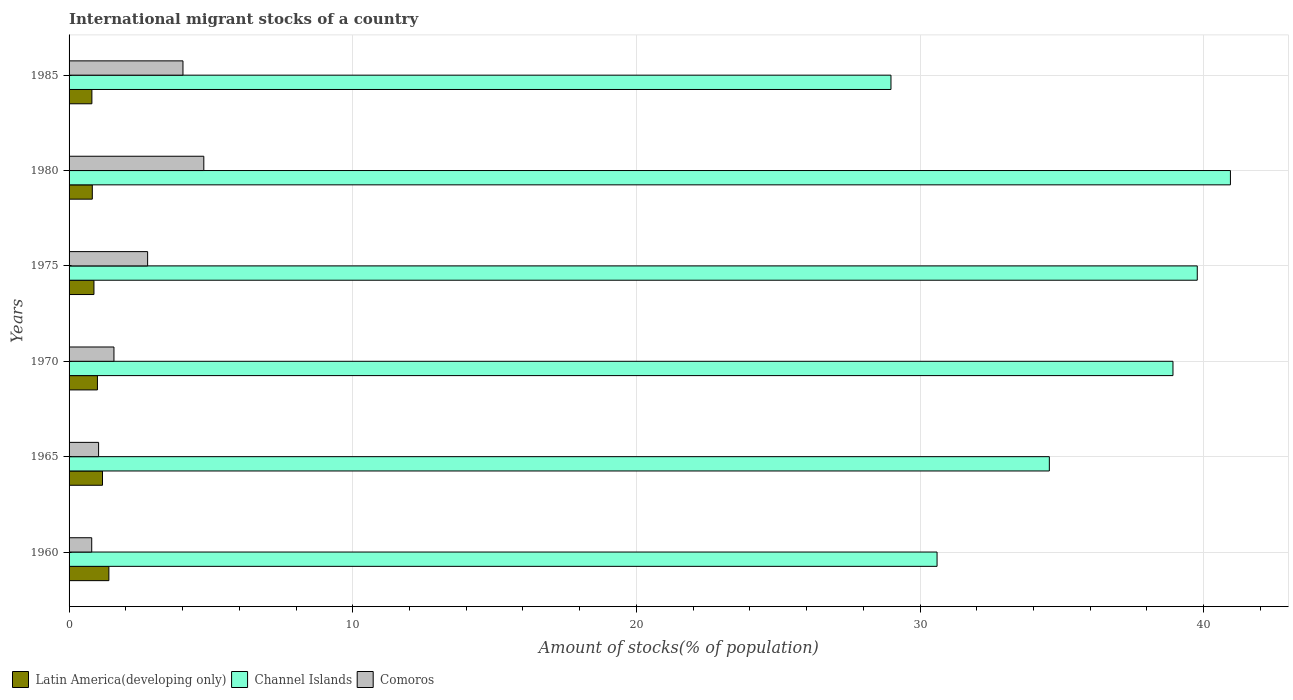How many different coloured bars are there?
Make the answer very short. 3. Are the number of bars on each tick of the Y-axis equal?
Your response must be concise. Yes. How many bars are there on the 4th tick from the top?
Your answer should be compact. 3. How many bars are there on the 6th tick from the bottom?
Offer a very short reply. 3. What is the label of the 5th group of bars from the top?
Keep it short and to the point. 1965. What is the amount of stocks in in Latin America(developing only) in 1985?
Provide a succinct answer. 0.8. Across all years, what is the maximum amount of stocks in in Channel Islands?
Offer a very short reply. 40.94. Across all years, what is the minimum amount of stocks in in Channel Islands?
Give a very brief answer. 28.98. In which year was the amount of stocks in in Latin America(developing only) maximum?
Provide a succinct answer. 1960. In which year was the amount of stocks in in Latin America(developing only) minimum?
Offer a very short reply. 1985. What is the total amount of stocks in in Channel Islands in the graph?
Ensure brevity in your answer.  213.76. What is the difference between the amount of stocks in in Channel Islands in 1970 and that in 1975?
Make the answer very short. -0.86. What is the difference between the amount of stocks in in Channel Islands in 1985 and the amount of stocks in in Comoros in 1975?
Your response must be concise. 26.21. What is the average amount of stocks in in Latin America(developing only) per year?
Provide a succinct answer. 1.01. In the year 1985, what is the difference between the amount of stocks in in Channel Islands and amount of stocks in in Latin America(developing only)?
Your response must be concise. 28.17. In how many years, is the amount of stocks in in Latin America(developing only) greater than 24 %?
Keep it short and to the point. 0. What is the ratio of the amount of stocks in in Latin America(developing only) in 1960 to that in 1985?
Your answer should be compact. 1.74. Is the amount of stocks in in Comoros in 1960 less than that in 1985?
Your response must be concise. Yes. What is the difference between the highest and the second highest amount of stocks in in Latin America(developing only)?
Make the answer very short. 0.22. What is the difference between the highest and the lowest amount of stocks in in Channel Islands?
Your answer should be very brief. 11.97. In how many years, is the amount of stocks in in Comoros greater than the average amount of stocks in in Comoros taken over all years?
Offer a very short reply. 3. Is the sum of the amount of stocks in in Comoros in 1960 and 1980 greater than the maximum amount of stocks in in Latin America(developing only) across all years?
Your response must be concise. Yes. What does the 2nd bar from the top in 1965 represents?
Your response must be concise. Channel Islands. What does the 3rd bar from the bottom in 1970 represents?
Make the answer very short. Comoros. What is the difference between two consecutive major ticks on the X-axis?
Your answer should be compact. 10. Where does the legend appear in the graph?
Provide a short and direct response. Bottom left. How many legend labels are there?
Provide a short and direct response. 3. What is the title of the graph?
Offer a very short reply. International migrant stocks of a country. Does "Andorra" appear as one of the legend labels in the graph?
Offer a very short reply. No. What is the label or title of the X-axis?
Provide a short and direct response. Amount of stocks(% of population). What is the label or title of the Y-axis?
Your answer should be compact. Years. What is the Amount of stocks(% of population) in Latin America(developing only) in 1960?
Offer a terse response. 1.4. What is the Amount of stocks(% of population) in Channel Islands in 1960?
Ensure brevity in your answer.  30.6. What is the Amount of stocks(% of population) in Comoros in 1960?
Offer a very short reply. 0.8. What is the Amount of stocks(% of population) of Latin America(developing only) in 1965?
Provide a short and direct response. 1.18. What is the Amount of stocks(% of population) of Channel Islands in 1965?
Make the answer very short. 34.56. What is the Amount of stocks(% of population) of Comoros in 1965?
Your response must be concise. 1.04. What is the Amount of stocks(% of population) in Latin America(developing only) in 1970?
Offer a very short reply. 1. What is the Amount of stocks(% of population) in Channel Islands in 1970?
Offer a very short reply. 38.92. What is the Amount of stocks(% of population) of Comoros in 1970?
Offer a very short reply. 1.58. What is the Amount of stocks(% of population) of Latin America(developing only) in 1975?
Provide a succinct answer. 0.88. What is the Amount of stocks(% of population) of Channel Islands in 1975?
Ensure brevity in your answer.  39.77. What is the Amount of stocks(% of population) of Comoros in 1975?
Ensure brevity in your answer.  2.77. What is the Amount of stocks(% of population) of Latin America(developing only) in 1980?
Your response must be concise. 0.82. What is the Amount of stocks(% of population) of Channel Islands in 1980?
Make the answer very short. 40.94. What is the Amount of stocks(% of population) in Comoros in 1980?
Your answer should be very brief. 4.75. What is the Amount of stocks(% of population) of Latin America(developing only) in 1985?
Provide a short and direct response. 0.8. What is the Amount of stocks(% of population) in Channel Islands in 1985?
Your response must be concise. 28.98. What is the Amount of stocks(% of population) in Comoros in 1985?
Your answer should be compact. 4.02. Across all years, what is the maximum Amount of stocks(% of population) in Latin America(developing only)?
Keep it short and to the point. 1.4. Across all years, what is the maximum Amount of stocks(% of population) in Channel Islands?
Provide a short and direct response. 40.94. Across all years, what is the maximum Amount of stocks(% of population) of Comoros?
Offer a terse response. 4.75. Across all years, what is the minimum Amount of stocks(% of population) in Latin America(developing only)?
Your answer should be compact. 0.8. Across all years, what is the minimum Amount of stocks(% of population) in Channel Islands?
Your answer should be compact. 28.98. Across all years, what is the minimum Amount of stocks(% of population) of Comoros?
Provide a short and direct response. 0.8. What is the total Amount of stocks(% of population) in Latin America(developing only) in the graph?
Keep it short and to the point. 6.08. What is the total Amount of stocks(% of population) of Channel Islands in the graph?
Offer a very short reply. 213.76. What is the total Amount of stocks(% of population) of Comoros in the graph?
Ensure brevity in your answer.  14.96. What is the difference between the Amount of stocks(% of population) in Latin America(developing only) in 1960 and that in 1965?
Give a very brief answer. 0.22. What is the difference between the Amount of stocks(% of population) of Channel Islands in 1960 and that in 1965?
Give a very brief answer. -3.96. What is the difference between the Amount of stocks(% of population) in Comoros in 1960 and that in 1965?
Provide a succinct answer. -0.24. What is the difference between the Amount of stocks(% of population) in Latin America(developing only) in 1960 and that in 1970?
Your response must be concise. 0.4. What is the difference between the Amount of stocks(% of population) of Channel Islands in 1960 and that in 1970?
Offer a terse response. -8.32. What is the difference between the Amount of stocks(% of population) in Comoros in 1960 and that in 1970?
Your answer should be very brief. -0.78. What is the difference between the Amount of stocks(% of population) in Latin America(developing only) in 1960 and that in 1975?
Provide a succinct answer. 0.53. What is the difference between the Amount of stocks(% of population) in Channel Islands in 1960 and that in 1975?
Make the answer very short. -9.17. What is the difference between the Amount of stocks(% of population) in Comoros in 1960 and that in 1975?
Ensure brevity in your answer.  -1.97. What is the difference between the Amount of stocks(% of population) in Latin America(developing only) in 1960 and that in 1980?
Your response must be concise. 0.58. What is the difference between the Amount of stocks(% of population) in Channel Islands in 1960 and that in 1980?
Make the answer very short. -10.34. What is the difference between the Amount of stocks(% of population) of Comoros in 1960 and that in 1980?
Give a very brief answer. -3.95. What is the difference between the Amount of stocks(% of population) in Latin America(developing only) in 1960 and that in 1985?
Your answer should be very brief. 0.6. What is the difference between the Amount of stocks(% of population) in Channel Islands in 1960 and that in 1985?
Your answer should be very brief. 1.62. What is the difference between the Amount of stocks(% of population) in Comoros in 1960 and that in 1985?
Your answer should be compact. -3.22. What is the difference between the Amount of stocks(% of population) of Latin America(developing only) in 1965 and that in 1970?
Ensure brevity in your answer.  0.18. What is the difference between the Amount of stocks(% of population) in Channel Islands in 1965 and that in 1970?
Give a very brief answer. -4.36. What is the difference between the Amount of stocks(% of population) of Comoros in 1965 and that in 1970?
Make the answer very short. -0.54. What is the difference between the Amount of stocks(% of population) in Latin America(developing only) in 1965 and that in 1975?
Ensure brevity in your answer.  0.3. What is the difference between the Amount of stocks(% of population) of Channel Islands in 1965 and that in 1975?
Your response must be concise. -5.22. What is the difference between the Amount of stocks(% of population) in Comoros in 1965 and that in 1975?
Your answer should be very brief. -1.73. What is the difference between the Amount of stocks(% of population) in Latin America(developing only) in 1965 and that in 1980?
Your response must be concise. 0.36. What is the difference between the Amount of stocks(% of population) of Channel Islands in 1965 and that in 1980?
Keep it short and to the point. -6.38. What is the difference between the Amount of stocks(% of population) in Comoros in 1965 and that in 1980?
Your response must be concise. -3.71. What is the difference between the Amount of stocks(% of population) of Latin America(developing only) in 1965 and that in 1985?
Provide a short and direct response. 0.37. What is the difference between the Amount of stocks(% of population) in Channel Islands in 1965 and that in 1985?
Your response must be concise. 5.58. What is the difference between the Amount of stocks(% of population) in Comoros in 1965 and that in 1985?
Ensure brevity in your answer.  -2.97. What is the difference between the Amount of stocks(% of population) in Latin America(developing only) in 1970 and that in 1975?
Ensure brevity in your answer.  0.12. What is the difference between the Amount of stocks(% of population) of Channel Islands in 1970 and that in 1975?
Provide a succinct answer. -0.86. What is the difference between the Amount of stocks(% of population) in Comoros in 1970 and that in 1975?
Make the answer very short. -1.19. What is the difference between the Amount of stocks(% of population) in Latin America(developing only) in 1970 and that in 1980?
Make the answer very short. 0.18. What is the difference between the Amount of stocks(% of population) in Channel Islands in 1970 and that in 1980?
Ensure brevity in your answer.  -2.03. What is the difference between the Amount of stocks(% of population) of Comoros in 1970 and that in 1980?
Your answer should be compact. -3.17. What is the difference between the Amount of stocks(% of population) in Latin America(developing only) in 1970 and that in 1985?
Give a very brief answer. 0.2. What is the difference between the Amount of stocks(% of population) of Channel Islands in 1970 and that in 1985?
Make the answer very short. 9.94. What is the difference between the Amount of stocks(% of population) of Comoros in 1970 and that in 1985?
Ensure brevity in your answer.  -2.43. What is the difference between the Amount of stocks(% of population) in Latin America(developing only) in 1975 and that in 1980?
Make the answer very short. 0.06. What is the difference between the Amount of stocks(% of population) in Channel Islands in 1975 and that in 1980?
Your response must be concise. -1.17. What is the difference between the Amount of stocks(% of population) in Comoros in 1975 and that in 1980?
Provide a succinct answer. -1.98. What is the difference between the Amount of stocks(% of population) of Latin America(developing only) in 1975 and that in 1985?
Offer a very short reply. 0.07. What is the difference between the Amount of stocks(% of population) in Channel Islands in 1975 and that in 1985?
Keep it short and to the point. 10.8. What is the difference between the Amount of stocks(% of population) in Comoros in 1975 and that in 1985?
Offer a very short reply. -1.25. What is the difference between the Amount of stocks(% of population) in Latin America(developing only) in 1980 and that in 1985?
Give a very brief answer. 0.02. What is the difference between the Amount of stocks(% of population) of Channel Islands in 1980 and that in 1985?
Keep it short and to the point. 11.97. What is the difference between the Amount of stocks(% of population) in Comoros in 1980 and that in 1985?
Offer a very short reply. 0.73. What is the difference between the Amount of stocks(% of population) of Latin America(developing only) in 1960 and the Amount of stocks(% of population) of Channel Islands in 1965?
Keep it short and to the point. -33.15. What is the difference between the Amount of stocks(% of population) in Latin America(developing only) in 1960 and the Amount of stocks(% of population) in Comoros in 1965?
Provide a succinct answer. 0.36. What is the difference between the Amount of stocks(% of population) in Channel Islands in 1960 and the Amount of stocks(% of population) in Comoros in 1965?
Your response must be concise. 29.56. What is the difference between the Amount of stocks(% of population) in Latin America(developing only) in 1960 and the Amount of stocks(% of population) in Channel Islands in 1970?
Offer a terse response. -37.51. What is the difference between the Amount of stocks(% of population) in Latin America(developing only) in 1960 and the Amount of stocks(% of population) in Comoros in 1970?
Offer a terse response. -0.18. What is the difference between the Amount of stocks(% of population) in Channel Islands in 1960 and the Amount of stocks(% of population) in Comoros in 1970?
Your response must be concise. 29.02. What is the difference between the Amount of stocks(% of population) in Latin America(developing only) in 1960 and the Amount of stocks(% of population) in Channel Islands in 1975?
Provide a short and direct response. -38.37. What is the difference between the Amount of stocks(% of population) of Latin America(developing only) in 1960 and the Amount of stocks(% of population) of Comoros in 1975?
Give a very brief answer. -1.37. What is the difference between the Amount of stocks(% of population) of Channel Islands in 1960 and the Amount of stocks(% of population) of Comoros in 1975?
Provide a short and direct response. 27.83. What is the difference between the Amount of stocks(% of population) in Latin America(developing only) in 1960 and the Amount of stocks(% of population) in Channel Islands in 1980?
Your answer should be very brief. -39.54. What is the difference between the Amount of stocks(% of population) of Latin America(developing only) in 1960 and the Amount of stocks(% of population) of Comoros in 1980?
Keep it short and to the point. -3.35. What is the difference between the Amount of stocks(% of population) in Channel Islands in 1960 and the Amount of stocks(% of population) in Comoros in 1980?
Offer a very short reply. 25.85. What is the difference between the Amount of stocks(% of population) of Latin America(developing only) in 1960 and the Amount of stocks(% of population) of Channel Islands in 1985?
Your response must be concise. -27.57. What is the difference between the Amount of stocks(% of population) in Latin America(developing only) in 1960 and the Amount of stocks(% of population) in Comoros in 1985?
Keep it short and to the point. -2.61. What is the difference between the Amount of stocks(% of population) of Channel Islands in 1960 and the Amount of stocks(% of population) of Comoros in 1985?
Offer a terse response. 26.58. What is the difference between the Amount of stocks(% of population) in Latin America(developing only) in 1965 and the Amount of stocks(% of population) in Channel Islands in 1970?
Your response must be concise. -37.74. What is the difference between the Amount of stocks(% of population) in Latin America(developing only) in 1965 and the Amount of stocks(% of population) in Comoros in 1970?
Provide a succinct answer. -0.4. What is the difference between the Amount of stocks(% of population) of Channel Islands in 1965 and the Amount of stocks(% of population) of Comoros in 1970?
Ensure brevity in your answer.  32.98. What is the difference between the Amount of stocks(% of population) in Latin America(developing only) in 1965 and the Amount of stocks(% of population) in Channel Islands in 1975?
Give a very brief answer. -38.59. What is the difference between the Amount of stocks(% of population) in Latin America(developing only) in 1965 and the Amount of stocks(% of population) in Comoros in 1975?
Ensure brevity in your answer.  -1.59. What is the difference between the Amount of stocks(% of population) of Channel Islands in 1965 and the Amount of stocks(% of population) of Comoros in 1975?
Offer a terse response. 31.79. What is the difference between the Amount of stocks(% of population) in Latin America(developing only) in 1965 and the Amount of stocks(% of population) in Channel Islands in 1980?
Offer a very short reply. -39.76. What is the difference between the Amount of stocks(% of population) in Latin America(developing only) in 1965 and the Amount of stocks(% of population) in Comoros in 1980?
Your answer should be compact. -3.57. What is the difference between the Amount of stocks(% of population) in Channel Islands in 1965 and the Amount of stocks(% of population) in Comoros in 1980?
Ensure brevity in your answer.  29.81. What is the difference between the Amount of stocks(% of population) in Latin America(developing only) in 1965 and the Amount of stocks(% of population) in Channel Islands in 1985?
Provide a short and direct response. -27.8. What is the difference between the Amount of stocks(% of population) in Latin America(developing only) in 1965 and the Amount of stocks(% of population) in Comoros in 1985?
Provide a succinct answer. -2.84. What is the difference between the Amount of stocks(% of population) of Channel Islands in 1965 and the Amount of stocks(% of population) of Comoros in 1985?
Give a very brief answer. 30.54. What is the difference between the Amount of stocks(% of population) of Latin America(developing only) in 1970 and the Amount of stocks(% of population) of Channel Islands in 1975?
Ensure brevity in your answer.  -38.77. What is the difference between the Amount of stocks(% of population) in Latin America(developing only) in 1970 and the Amount of stocks(% of population) in Comoros in 1975?
Your answer should be very brief. -1.77. What is the difference between the Amount of stocks(% of population) of Channel Islands in 1970 and the Amount of stocks(% of population) of Comoros in 1975?
Provide a short and direct response. 36.15. What is the difference between the Amount of stocks(% of population) in Latin America(developing only) in 1970 and the Amount of stocks(% of population) in Channel Islands in 1980?
Your response must be concise. -39.94. What is the difference between the Amount of stocks(% of population) of Latin America(developing only) in 1970 and the Amount of stocks(% of population) of Comoros in 1980?
Your answer should be compact. -3.75. What is the difference between the Amount of stocks(% of population) in Channel Islands in 1970 and the Amount of stocks(% of population) in Comoros in 1980?
Give a very brief answer. 34.17. What is the difference between the Amount of stocks(% of population) of Latin America(developing only) in 1970 and the Amount of stocks(% of population) of Channel Islands in 1985?
Give a very brief answer. -27.98. What is the difference between the Amount of stocks(% of population) of Latin America(developing only) in 1970 and the Amount of stocks(% of population) of Comoros in 1985?
Provide a succinct answer. -3.02. What is the difference between the Amount of stocks(% of population) in Channel Islands in 1970 and the Amount of stocks(% of population) in Comoros in 1985?
Your answer should be compact. 34.9. What is the difference between the Amount of stocks(% of population) of Latin America(developing only) in 1975 and the Amount of stocks(% of population) of Channel Islands in 1980?
Your response must be concise. -40.06. What is the difference between the Amount of stocks(% of population) of Latin America(developing only) in 1975 and the Amount of stocks(% of population) of Comoros in 1980?
Your answer should be very brief. -3.87. What is the difference between the Amount of stocks(% of population) of Channel Islands in 1975 and the Amount of stocks(% of population) of Comoros in 1980?
Your answer should be very brief. 35.02. What is the difference between the Amount of stocks(% of population) of Latin America(developing only) in 1975 and the Amount of stocks(% of population) of Channel Islands in 1985?
Your answer should be very brief. -28.1. What is the difference between the Amount of stocks(% of population) of Latin America(developing only) in 1975 and the Amount of stocks(% of population) of Comoros in 1985?
Your answer should be very brief. -3.14. What is the difference between the Amount of stocks(% of population) in Channel Islands in 1975 and the Amount of stocks(% of population) in Comoros in 1985?
Provide a short and direct response. 35.76. What is the difference between the Amount of stocks(% of population) in Latin America(developing only) in 1980 and the Amount of stocks(% of population) in Channel Islands in 1985?
Offer a very short reply. -28.16. What is the difference between the Amount of stocks(% of population) in Latin America(developing only) in 1980 and the Amount of stocks(% of population) in Comoros in 1985?
Your answer should be very brief. -3.2. What is the difference between the Amount of stocks(% of population) in Channel Islands in 1980 and the Amount of stocks(% of population) in Comoros in 1985?
Give a very brief answer. 36.93. What is the average Amount of stocks(% of population) in Latin America(developing only) per year?
Give a very brief answer. 1.01. What is the average Amount of stocks(% of population) of Channel Islands per year?
Your answer should be very brief. 35.63. What is the average Amount of stocks(% of population) in Comoros per year?
Your response must be concise. 2.49. In the year 1960, what is the difference between the Amount of stocks(% of population) of Latin America(developing only) and Amount of stocks(% of population) of Channel Islands?
Make the answer very short. -29.2. In the year 1960, what is the difference between the Amount of stocks(% of population) of Latin America(developing only) and Amount of stocks(% of population) of Comoros?
Make the answer very short. 0.6. In the year 1960, what is the difference between the Amount of stocks(% of population) in Channel Islands and Amount of stocks(% of population) in Comoros?
Give a very brief answer. 29.8. In the year 1965, what is the difference between the Amount of stocks(% of population) in Latin America(developing only) and Amount of stocks(% of population) in Channel Islands?
Offer a terse response. -33.38. In the year 1965, what is the difference between the Amount of stocks(% of population) in Latin America(developing only) and Amount of stocks(% of population) in Comoros?
Your answer should be compact. 0.14. In the year 1965, what is the difference between the Amount of stocks(% of population) in Channel Islands and Amount of stocks(% of population) in Comoros?
Provide a succinct answer. 33.52. In the year 1970, what is the difference between the Amount of stocks(% of population) of Latin America(developing only) and Amount of stocks(% of population) of Channel Islands?
Keep it short and to the point. -37.92. In the year 1970, what is the difference between the Amount of stocks(% of population) of Latin America(developing only) and Amount of stocks(% of population) of Comoros?
Offer a very short reply. -0.58. In the year 1970, what is the difference between the Amount of stocks(% of population) in Channel Islands and Amount of stocks(% of population) in Comoros?
Offer a very short reply. 37.33. In the year 1975, what is the difference between the Amount of stocks(% of population) in Latin America(developing only) and Amount of stocks(% of population) in Channel Islands?
Make the answer very short. -38.9. In the year 1975, what is the difference between the Amount of stocks(% of population) in Latin America(developing only) and Amount of stocks(% of population) in Comoros?
Offer a terse response. -1.89. In the year 1975, what is the difference between the Amount of stocks(% of population) in Channel Islands and Amount of stocks(% of population) in Comoros?
Provide a succinct answer. 37. In the year 1980, what is the difference between the Amount of stocks(% of population) in Latin America(developing only) and Amount of stocks(% of population) in Channel Islands?
Make the answer very short. -40.12. In the year 1980, what is the difference between the Amount of stocks(% of population) in Latin America(developing only) and Amount of stocks(% of population) in Comoros?
Provide a short and direct response. -3.93. In the year 1980, what is the difference between the Amount of stocks(% of population) of Channel Islands and Amount of stocks(% of population) of Comoros?
Provide a succinct answer. 36.19. In the year 1985, what is the difference between the Amount of stocks(% of population) of Latin America(developing only) and Amount of stocks(% of population) of Channel Islands?
Ensure brevity in your answer.  -28.17. In the year 1985, what is the difference between the Amount of stocks(% of population) of Latin America(developing only) and Amount of stocks(% of population) of Comoros?
Ensure brevity in your answer.  -3.21. In the year 1985, what is the difference between the Amount of stocks(% of population) of Channel Islands and Amount of stocks(% of population) of Comoros?
Provide a short and direct response. 24.96. What is the ratio of the Amount of stocks(% of population) of Latin America(developing only) in 1960 to that in 1965?
Offer a terse response. 1.19. What is the ratio of the Amount of stocks(% of population) of Channel Islands in 1960 to that in 1965?
Ensure brevity in your answer.  0.89. What is the ratio of the Amount of stocks(% of population) in Comoros in 1960 to that in 1965?
Your answer should be very brief. 0.77. What is the ratio of the Amount of stocks(% of population) in Latin America(developing only) in 1960 to that in 1970?
Offer a very short reply. 1.4. What is the ratio of the Amount of stocks(% of population) in Channel Islands in 1960 to that in 1970?
Give a very brief answer. 0.79. What is the ratio of the Amount of stocks(% of population) in Comoros in 1960 to that in 1970?
Offer a very short reply. 0.5. What is the ratio of the Amount of stocks(% of population) of Latin America(developing only) in 1960 to that in 1975?
Give a very brief answer. 1.6. What is the ratio of the Amount of stocks(% of population) of Channel Islands in 1960 to that in 1975?
Offer a terse response. 0.77. What is the ratio of the Amount of stocks(% of population) in Comoros in 1960 to that in 1975?
Your response must be concise. 0.29. What is the ratio of the Amount of stocks(% of population) in Latin America(developing only) in 1960 to that in 1980?
Provide a succinct answer. 1.71. What is the ratio of the Amount of stocks(% of population) in Channel Islands in 1960 to that in 1980?
Give a very brief answer. 0.75. What is the ratio of the Amount of stocks(% of population) of Comoros in 1960 to that in 1980?
Ensure brevity in your answer.  0.17. What is the ratio of the Amount of stocks(% of population) of Latin America(developing only) in 1960 to that in 1985?
Ensure brevity in your answer.  1.74. What is the ratio of the Amount of stocks(% of population) in Channel Islands in 1960 to that in 1985?
Keep it short and to the point. 1.06. What is the ratio of the Amount of stocks(% of population) in Comoros in 1960 to that in 1985?
Offer a very short reply. 0.2. What is the ratio of the Amount of stocks(% of population) of Latin America(developing only) in 1965 to that in 1970?
Your answer should be very brief. 1.18. What is the ratio of the Amount of stocks(% of population) of Channel Islands in 1965 to that in 1970?
Your response must be concise. 0.89. What is the ratio of the Amount of stocks(% of population) of Comoros in 1965 to that in 1970?
Ensure brevity in your answer.  0.66. What is the ratio of the Amount of stocks(% of population) in Latin America(developing only) in 1965 to that in 1975?
Offer a very short reply. 1.34. What is the ratio of the Amount of stocks(% of population) of Channel Islands in 1965 to that in 1975?
Keep it short and to the point. 0.87. What is the ratio of the Amount of stocks(% of population) in Comoros in 1965 to that in 1975?
Ensure brevity in your answer.  0.38. What is the ratio of the Amount of stocks(% of population) in Latin America(developing only) in 1965 to that in 1980?
Your answer should be very brief. 1.44. What is the ratio of the Amount of stocks(% of population) in Channel Islands in 1965 to that in 1980?
Ensure brevity in your answer.  0.84. What is the ratio of the Amount of stocks(% of population) in Comoros in 1965 to that in 1980?
Your answer should be compact. 0.22. What is the ratio of the Amount of stocks(% of population) in Latin America(developing only) in 1965 to that in 1985?
Offer a very short reply. 1.47. What is the ratio of the Amount of stocks(% of population) of Channel Islands in 1965 to that in 1985?
Your response must be concise. 1.19. What is the ratio of the Amount of stocks(% of population) of Comoros in 1965 to that in 1985?
Provide a short and direct response. 0.26. What is the ratio of the Amount of stocks(% of population) in Latin America(developing only) in 1970 to that in 1975?
Keep it short and to the point. 1.14. What is the ratio of the Amount of stocks(% of population) of Channel Islands in 1970 to that in 1975?
Make the answer very short. 0.98. What is the ratio of the Amount of stocks(% of population) in Comoros in 1970 to that in 1975?
Your response must be concise. 0.57. What is the ratio of the Amount of stocks(% of population) in Latin America(developing only) in 1970 to that in 1980?
Your answer should be compact. 1.22. What is the ratio of the Amount of stocks(% of population) in Channel Islands in 1970 to that in 1980?
Your response must be concise. 0.95. What is the ratio of the Amount of stocks(% of population) of Comoros in 1970 to that in 1980?
Offer a very short reply. 0.33. What is the ratio of the Amount of stocks(% of population) of Latin America(developing only) in 1970 to that in 1985?
Provide a succinct answer. 1.24. What is the ratio of the Amount of stocks(% of population) of Channel Islands in 1970 to that in 1985?
Provide a succinct answer. 1.34. What is the ratio of the Amount of stocks(% of population) of Comoros in 1970 to that in 1985?
Your response must be concise. 0.39. What is the ratio of the Amount of stocks(% of population) of Latin America(developing only) in 1975 to that in 1980?
Your answer should be compact. 1.07. What is the ratio of the Amount of stocks(% of population) in Channel Islands in 1975 to that in 1980?
Your response must be concise. 0.97. What is the ratio of the Amount of stocks(% of population) of Comoros in 1975 to that in 1980?
Provide a short and direct response. 0.58. What is the ratio of the Amount of stocks(% of population) in Latin America(developing only) in 1975 to that in 1985?
Your response must be concise. 1.09. What is the ratio of the Amount of stocks(% of population) of Channel Islands in 1975 to that in 1985?
Your response must be concise. 1.37. What is the ratio of the Amount of stocks(% of population) of Comoros in 1975 to that in 1985?
Ensure brevity in your answer.  0.69. What is the ratio of the Amount of stocks(% of population) of Latin America(developing only) in 1980 to that in 1985?
Offer a terse response. 1.02. What is the ratio of the Amount of stocks(% of population) in Channel Islands in 1980 to that in 1985?
Make the answer very short. 1.41. What is the ratio of the Amount of stocks(% of population) of Comoros in 1980 to that in 1985?
Provide a succinct answer. 1.18. What is the difference between the highest and the second highest Amount of stocks(% of population) of Latin America(developing only)?
Your response must be concise. 0.22. What is the difference between the highest and the second highest Amount of stocks(% of population) of Channel Islands?
Your response must be concise. 1.17. What is the difference between the highest and the second highest Amount of stocks(% of population) in Comoros?
Give a very brief answer. 0.73. What is the difference between the highest and the lowest Amount of stocks(% of population) of Latin America(developing only)?
Ensure brevity in your answer.  0.6. What is the difference between the highest and the lowest Amount of stocks(% of population) in Channel Islands?
Offer a very short reply. 11.97. What is the difference between the highest and the lowest Amount of stocks(% of population) of Comoros?
Give a very brief answer. 3.95. 